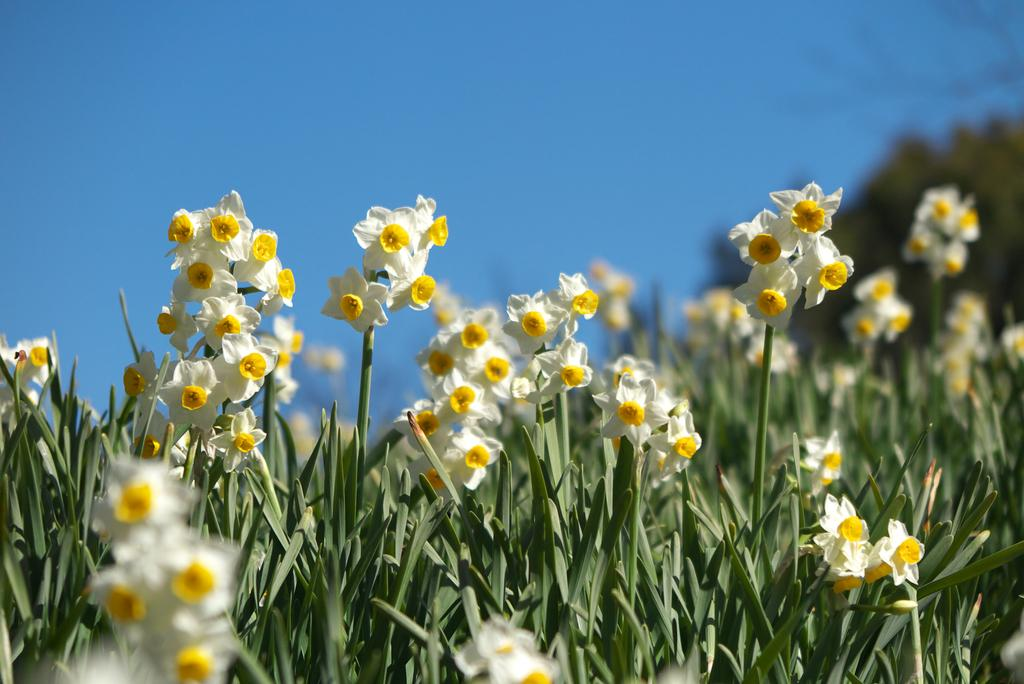What type of vegetation is present in the image? There is grass and plants in the image. Are there any specific flowers visible in the image? Yes, there are white flowers in the image. What is the condition of the sky in the image? The sky is clear in the image. What color is the coat worn by the wind in the image? There is no wind or coat present in the image. What is the chance of rain in the image? The image does not provide any information about the weather or the chance of rain. 